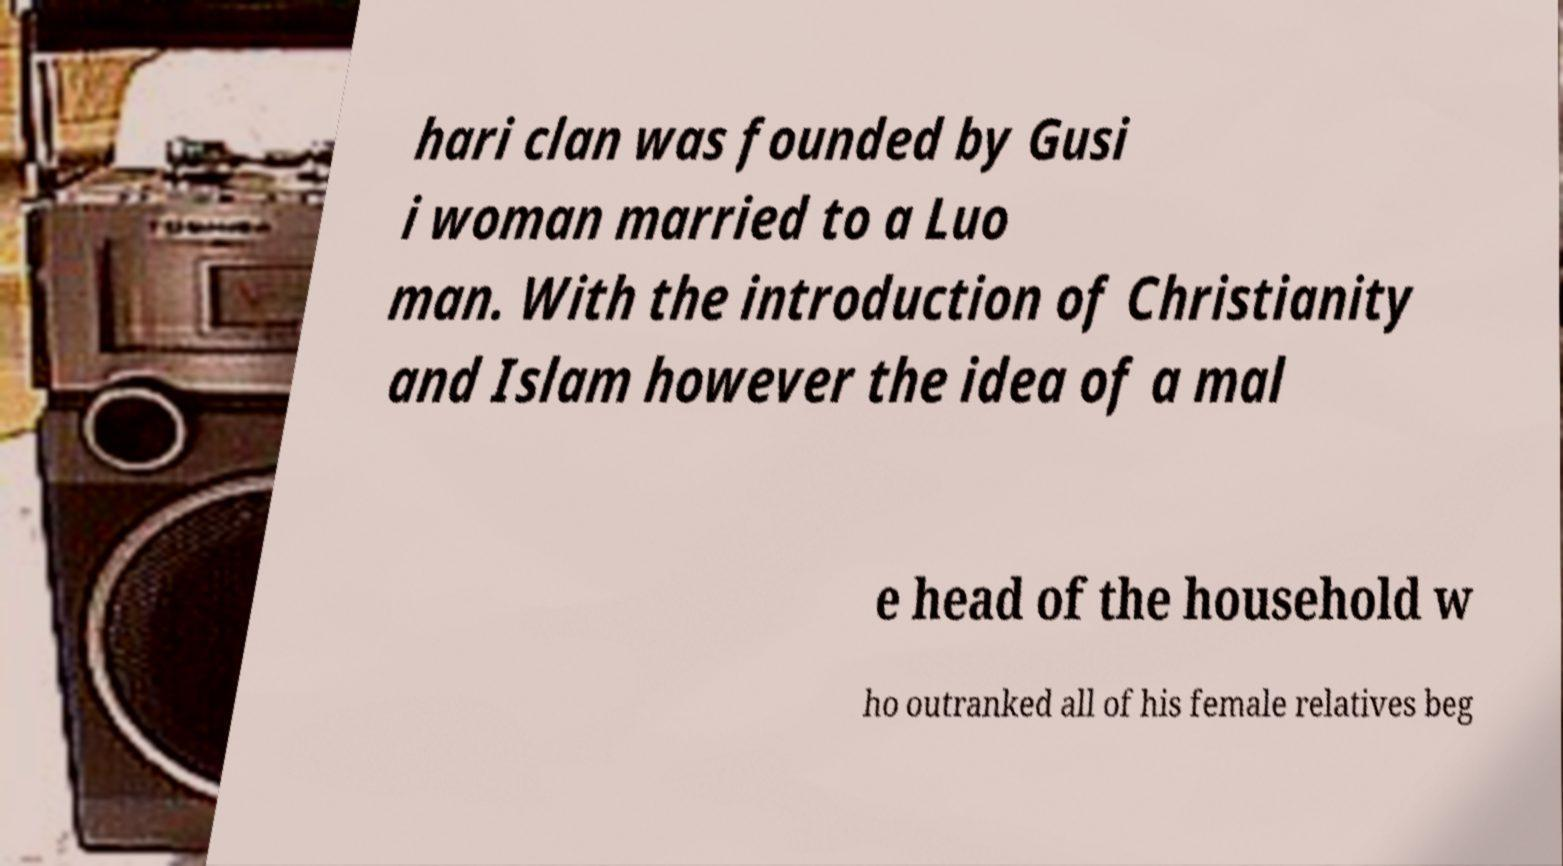Could you extract and type out the text from this image? hari clan was founded by Gusi i woman married to a Luo man. With the introduction of Christianity and Islam however the idea of a mal e head of the household w ho outranked all of his female relatives beg 